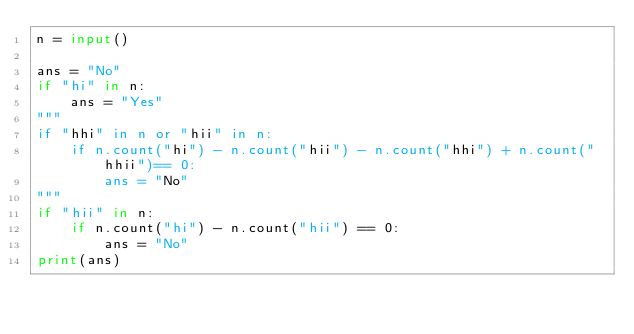<code> <loc_0><loc_0><loc_500><loc_500><_Python_>n = input()

ans = "No"
if "hi" in n:
    ans = "Yes"
"""
if "hhi" in n or "hii" in n:
    if n.count("hi") - n.count("hii") - n.count("hhi") + n.count("hhii")== 0:
        ans = "No"
"""
if "hii" in n:
    if n.count("hi") - n.count("hii") == 0:
        ans = "No"
print(ans)</code> 